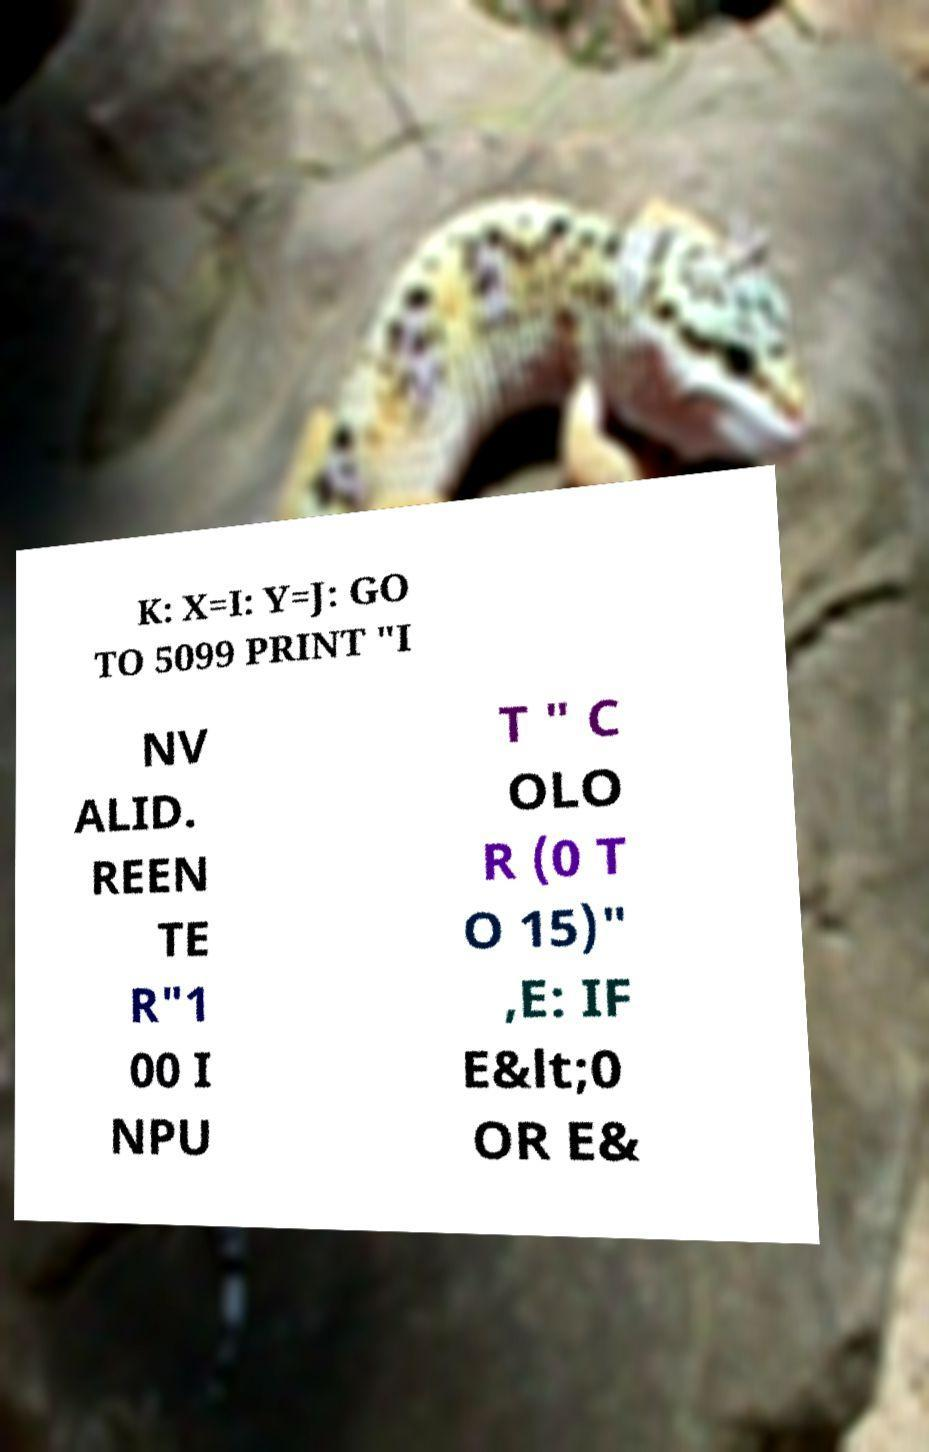Can you read and provide the text displayed in the image?This photo seems to have some interesting text. Can you extract and type it out for me? K: X=I: Y=J: GO TO 5099 PRINT "I NV ALID. REEN TE R"1 00 I NPU T " C OLO R (0 T O 15)" ,E: IF E&lt;0 OR E& 